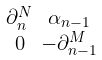<formula> <loc_0><loc_0><loc_500><loc_500>\begin{smallmatrix} \partial _ { n } ^ { N } & \alpha _ { n - 1 } \\ 0 & - \partial _ { n - 1 } ^ { M } \end{smallmatrix}</formula> 